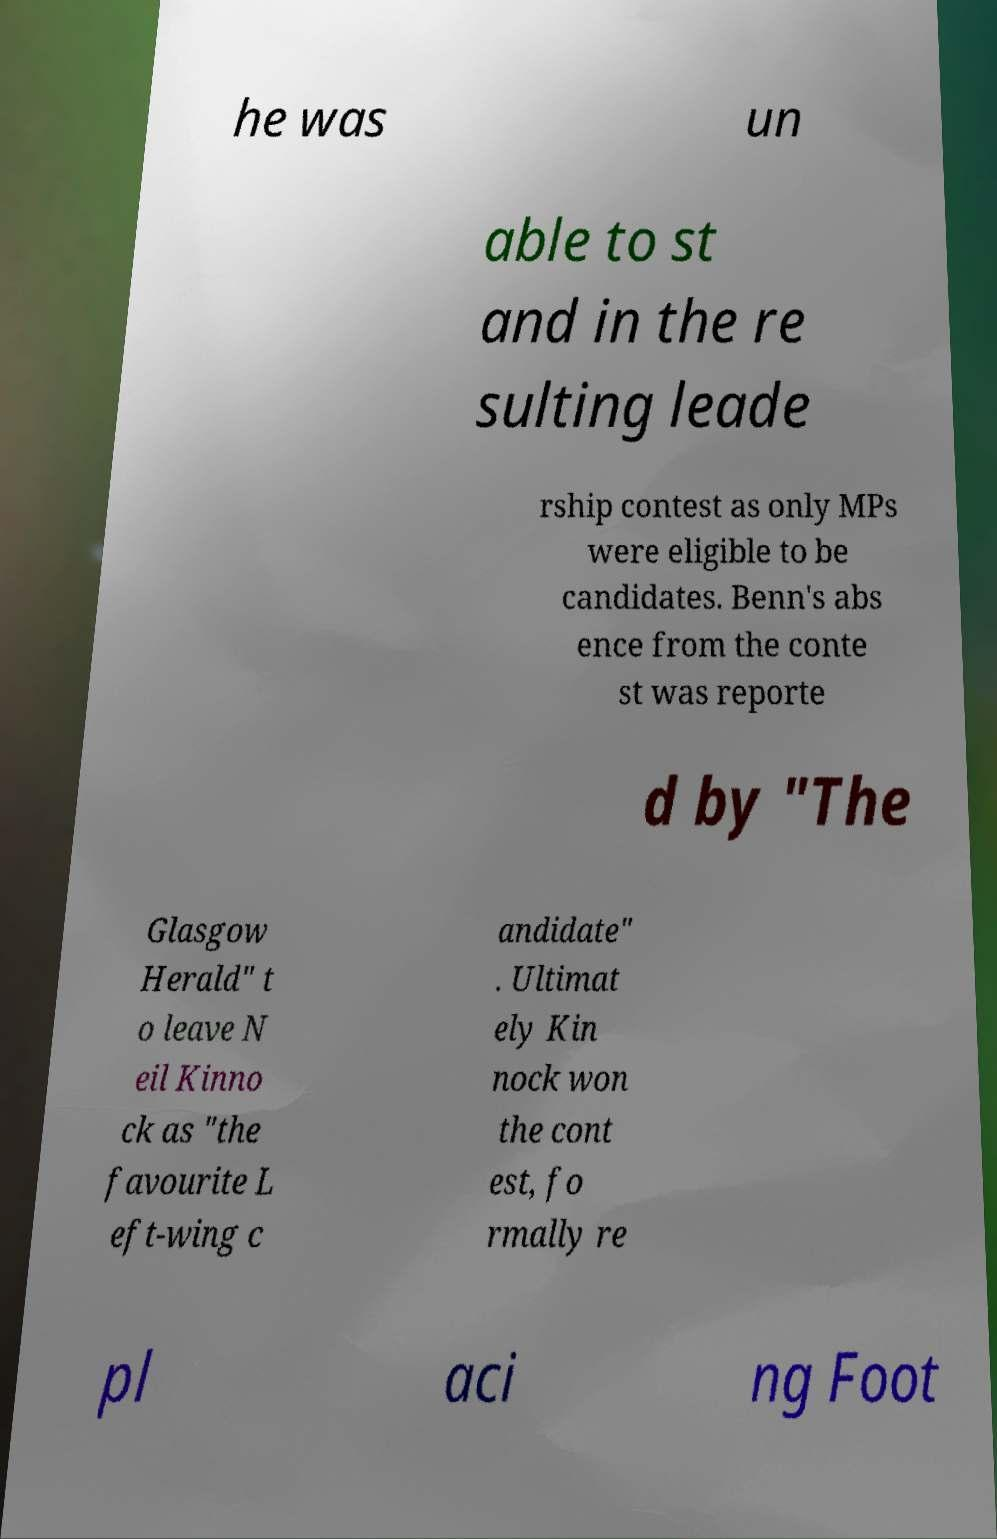Please identify and transcribe the text found in this image. he was un able to st and in the re sulting leade rship contest as only MPs were eligible to be candidates. Benn's abs ence from the conte st was reporte d by "The Glasgow Herald" t o leave N eil Kinno ck as "the favourite L eft-wing c andidate" . Ultimat ely Kin nock won the cont est, fo rmally re pl aci ng Foot 